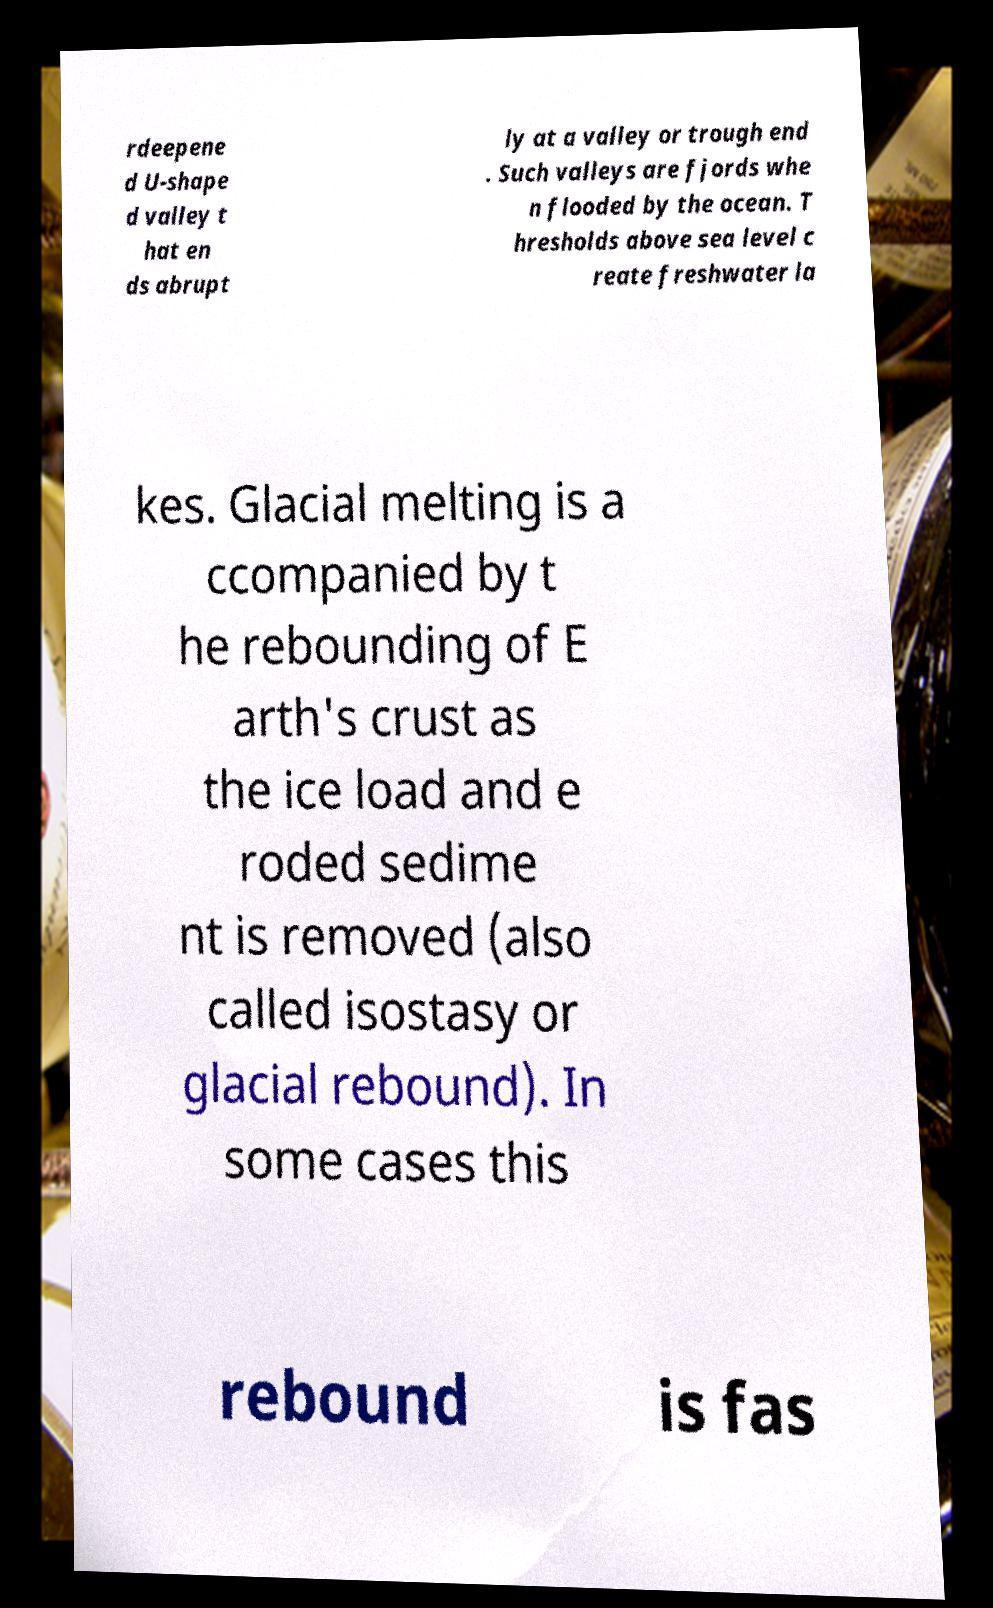I need the written content from this picture converted into text. Can you do that? rdeepene d U-shape d valley t hat en ds abrupt ly at a valley or trough end . Such valleys are fjords whe n flooded by the ocean. T hresholds above sea level c reate freshwater la kes. Glacial melting is a ccompanied by t he rebounding of E arth's crust as the ice load and e roded sedime nt is removed (also called isostasy or glacial rebound). In some cases this rebound is fas 